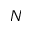Convert formula to latex. <formula><loc_0><loc_0><loc_500><loc_500>N</formula> 